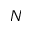Convert formula to latex. <formula><loc_0><loc_0><loc_500><loc_500>N</formula> 